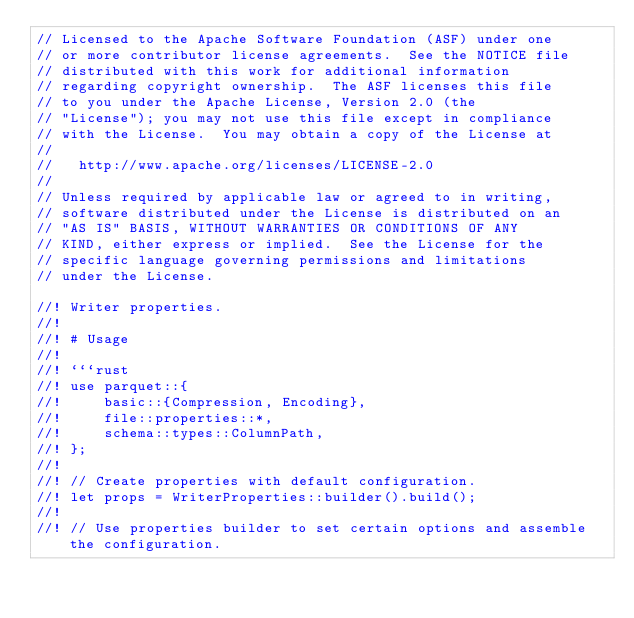Convert code to text. <code><loc_0><loc_0><loc_500><loc_500><_Rust_>// Licensed to the Apache Software Foundation (ASF) under one
// or more contributor license agreements.  See the NOTICE file
// distributed with this work for additional information
// regarding copyright ownership.  The ASF licenses this file
// to you under the Apache License, Version 2.0 (the
// "License"); you may not use this file except in compliance
// with the License.  You may obtain a copy of the License at
//
//   http://www.apache.org/licenses/LICENSE-2.0
//
// Unless required by applicable law or agreed to in writing,
// software distributed under the License is distributed on an
// "AS IS" BASIS, WITHOUT WARRANTIES OR CONDITIONS OF ANY
// KIND, either express or implied.  See the License for the
// specific language governing permissions and limitations
// under the License.

//! Writer properties.
//!
//! # Usage
//!
//! ```rust
//! use parquet::{
//!     basic::{Compression, Encoding},
//!     file::properties::*,
//!     schema::types::ColumnPath,
//! };
//!
//! // Create properties with default configuration.
//! let props = WriterProperties::builder().build();
//!
//! // Use properties builder to set certain options and assemble the configuration.</code> 